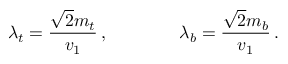<formula> <loc_0><loc_0><loc_500><loc_500>\lambda _ { t } = \frac { \sqrt { 2 } m _ { t } } { v _ { 1 } } \, , \quad \lambda _ { b } = \frac { \sqrt { 2 } m _ { b } } { v _ { 1 } } \, .</formula> 